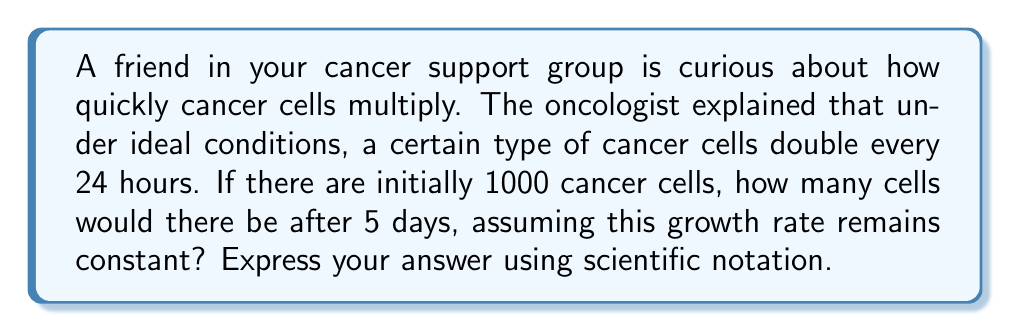Give your solution to this math problem. Let's approach this step-by-step:

1) First, we need to recognize that this is an exponential growth problem. The general form of an exponential growth function is:

   $$N(t) = N_0 \cdot e^{rt}$$

   Where:
   $N(t)$ is the number of cells at time $t$
   $N_0$ is the initial number of cells
   $r$ is the growth rate
   $t$ is the time

2) We're told that the cells double every 24 hours. We can use this to find $r$:

   $$2 = e^{r \cdot 1}$$
   $$\ln(2) = r$$
   $$r = 0.693$$

3) Now we have:
   $N_0 = 1000$ (initial number of cells)
   $r = 0.693$ (growth rate)
   $t = 5$ (days)

4) Plugging these into our exponential growth formula:

   $$N(5) = 1000 \cdot e^{0.693 \cdot 5}$$

5) Let's calculate this:
   $$N(5) = 1000 \cdot e^{3.465}$$
   $$N(5) = 1000 \cdot 31.97$$
   $$N(5) = 31,970$$

6) Converting to scientific notation:
   $$N(5) = 3.197 \times 10^4$$
Answer: $3.197 \times 10^4$ cells 